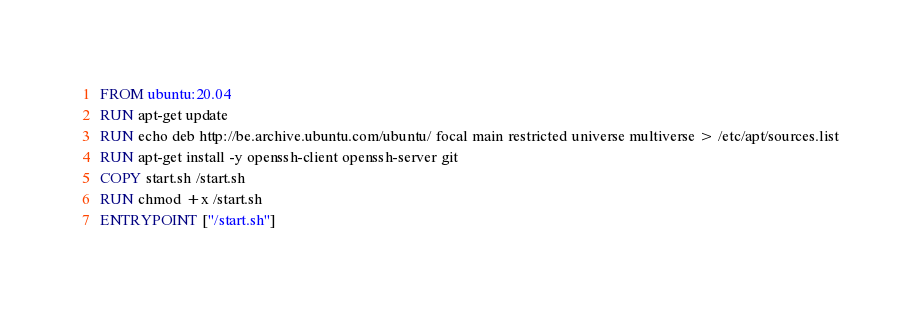<code> <loc_0><loc_0><loc_500><loc_500><_Dockerfile_>FROM ubuntu:20.04
RUN apt-get update
RUN echo deb http://be.archive.ubuntu.com/ubuntu/ focal main restricted universe multiverse > /etc/apt/sources.list
RUN apt-get install -y openssh-client openssh-server git
COPY start.sh /start.sh
RUN chmod +x /start.sh
ENTRYPOINT ["/start.sh"]
</code> 